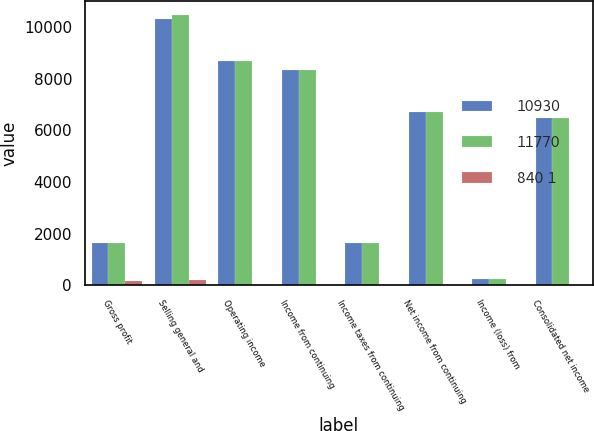Convert chart. <chart><loc_0><loc_0><loc_500><loc_500><stacked_bar_chart><ecel><fcel>Gross profit<fcel>Selling general and<fcel>Operating income<fcel>Income from continuing<fcel>Income taxes from continuing<fcel>Net income from continuing<fcel>Income (loss) from<fcel>Consolidated net income<nl><fcel>10930<fcel>1624.5<fcel>10307<fcel>8700<fcel>8350<fcel>1623<fcel>6727<fcel>251<fcel>6476<nl><fcel>11770<fcel>1624.5<fcel>10488<fcel>8694<fcel>8344<fcel>1626<fcel>6718<fcel>253<fcel>6465<nl><fcel>840 1<fcel>175<fcel>181<fcel>6<fcel>6<fcel>3<fcel>9<fcel>2<fcel>11<nl></chart> 